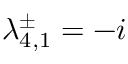<formula> <loc_0><loc_0><loc_500><loc_500>\lambda _ { 4 , 1 } ^ { \pm } = - i</formula> 